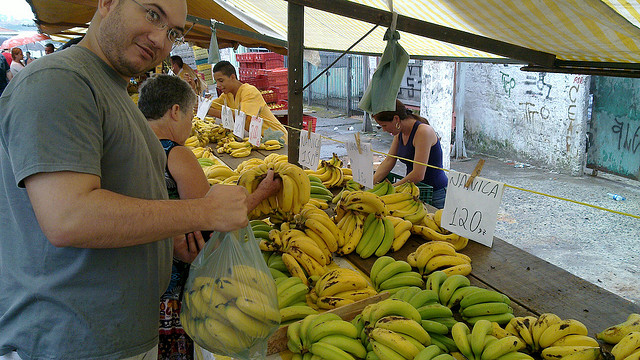Extract all visible text content from this image. 120 NANIC 